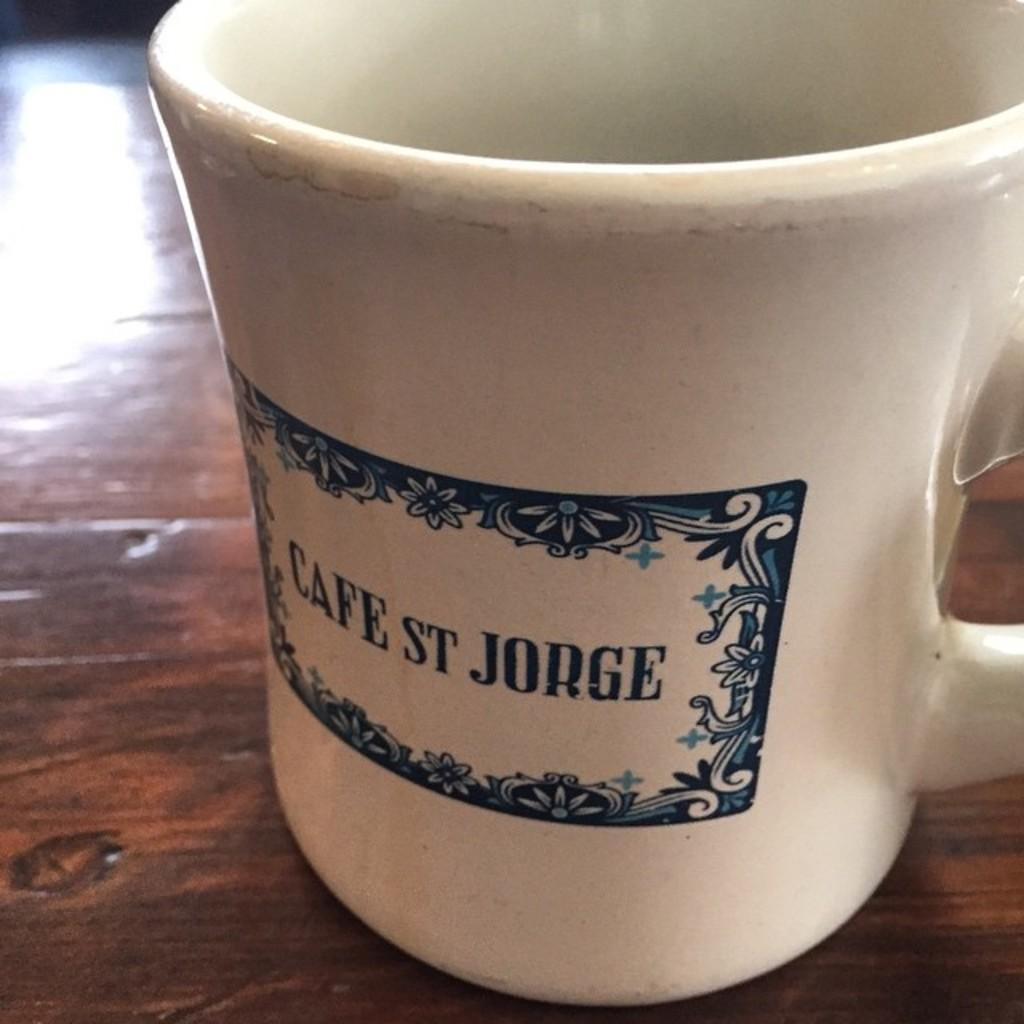Provide a one-sentence caption for the provided image. The mug on the table is from Cafe ST Jorge. 